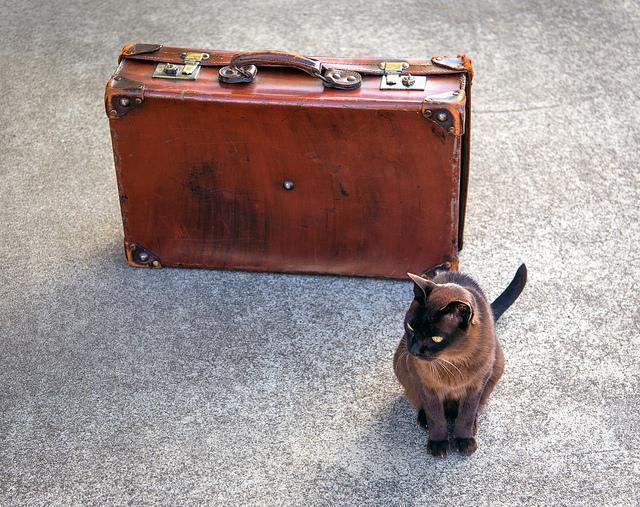How many suitcases are visible?
Give a very brief answer. 1. How many headlights does this truck have?
Give a very brief answer. 0. 